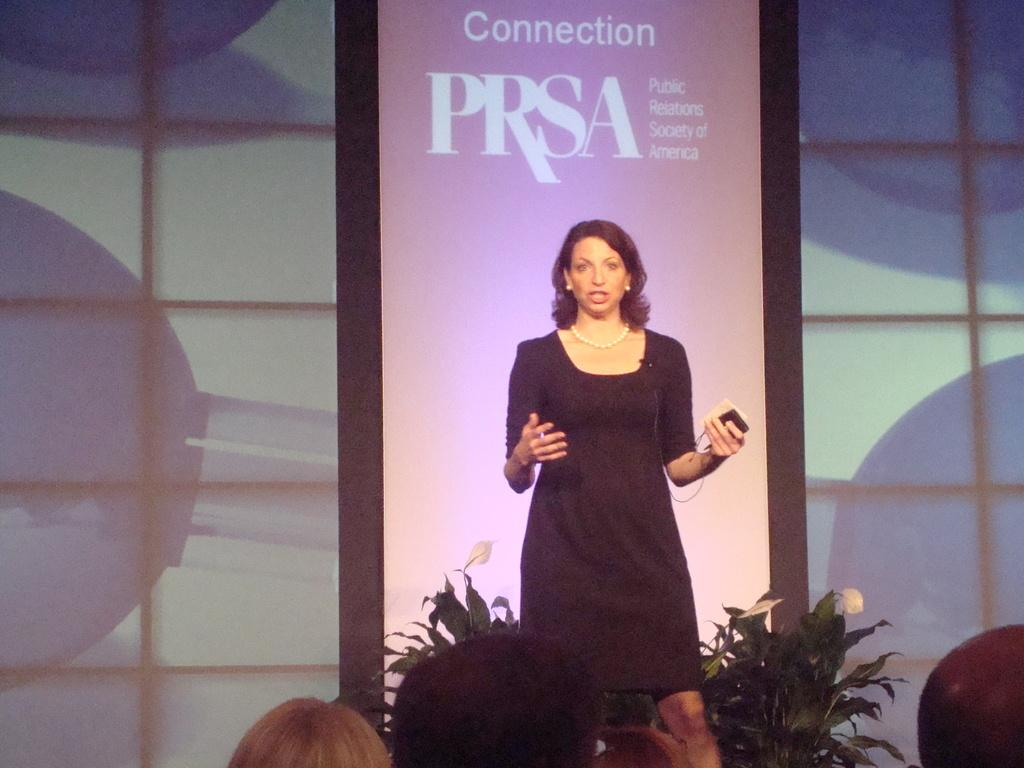What is the woman doing in the image? The woman is standing and talking in the image. What is the woman holding in her hand? The woman is holding an object in her hand. What can be seen behind the woman in the image? There is a banner with text behind the woman. What type of vegetation is present in the image? There are plants in the image. What type of sack can be seen hanging from the banner in the image? There is no sack hanging from the banner in the image. Can you see a kitty playing with the plants in the image? There is no kitty present in the image. 